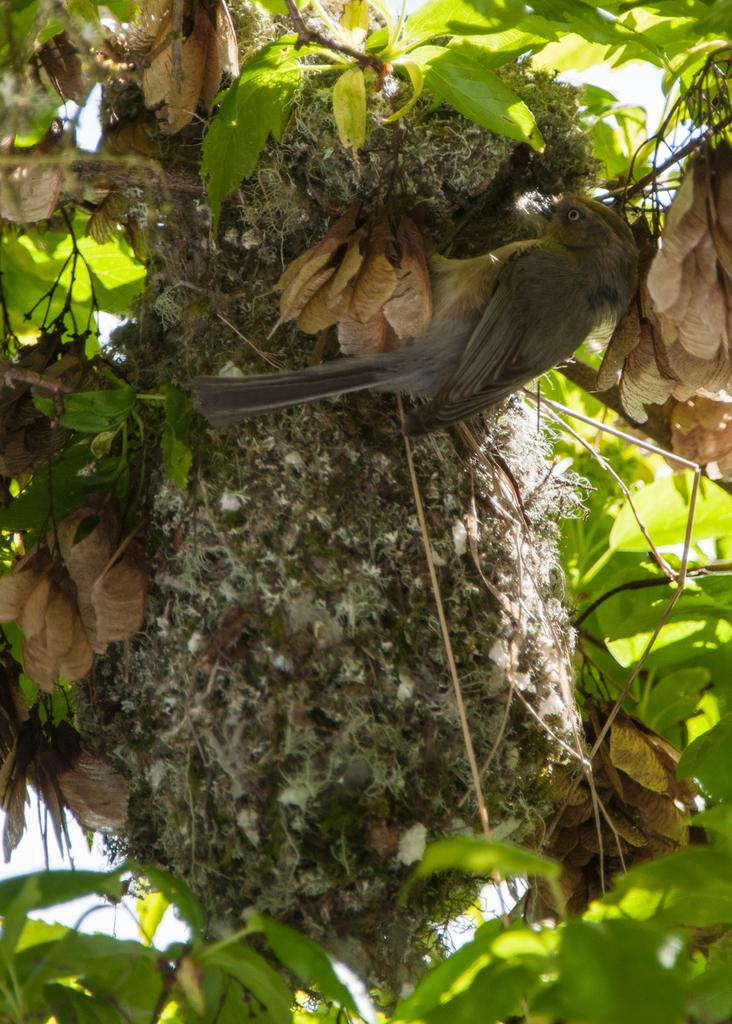What is located in the tree in the image? There is a nest in the tree. Is there anything on the nest? Yes, there is a bird on the nest. Where is the team's toothbrush located in the image? There is no toothbrush or team present in the image; it features a nest with a bird. 